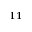<formula> <loc_0><loc_0><loc_500><loc_500>^ { 1 1 }</formula> 